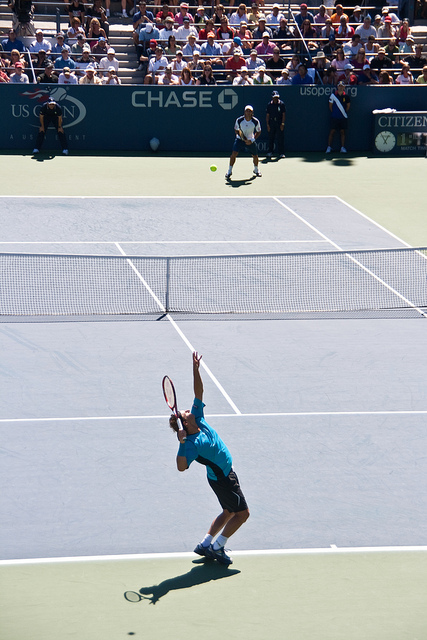Read and extract the text from this image. CHASE US CITIZEN 